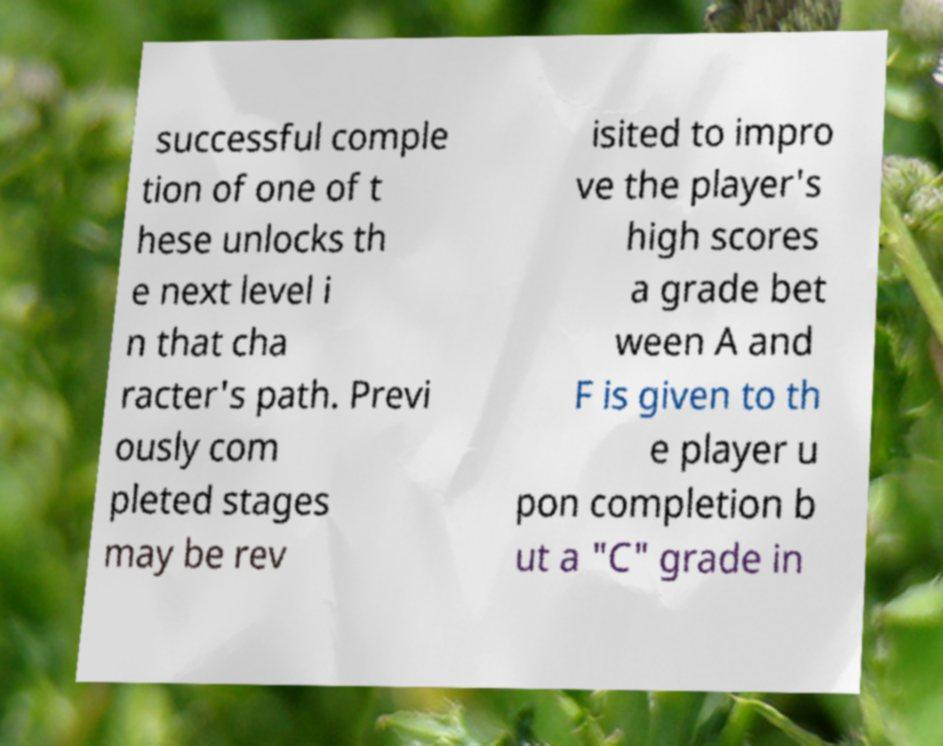There's text embedded in this image that I need extracted. Can you transcribe it verbatim? successful comple tion of one of t hese unlocks th e next level i n that cha racter's path. Previ ously com pleted stages may be rev isited to impro ve the player's high scores a grade bet ween A and F is given to th e player u pon completion b ut a "C" grade in 